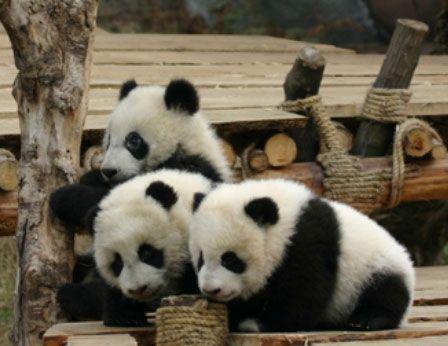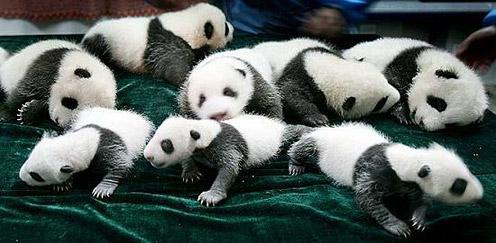The first image is the image on the left, the second image is the image on the right. For the images shown, is this caption "Each image contains a single panda, and one image shows a panda reaching one paw toward a manmade object with a squarish base." true? Answer yes or no. No. The first image is the image on the left, the second image is the image on the right. Evaluate the accuracy of this statement regarding the images: "The panda on the left is shown with some green bamboo.". Is it true? Answer yes or no. No. 